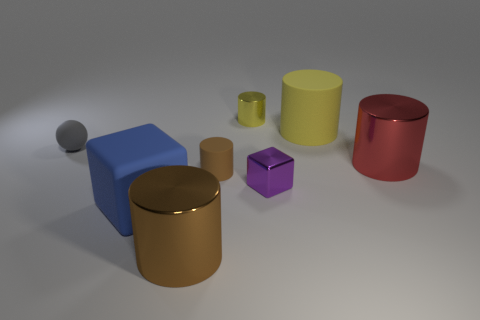Subtract all brown shiny cylinders. How many cylinders are left? 4 Subtract all red cylinders. How many cylinders are left? 4 Add 1 tiny balls. How many objects exist? 9 Subtract all blue cylinders. Subtract all cyan spheres. How many cylinders are left? 5 Subtract all cylinders. How many objects are left? 3 Subtract all rubber cylinders. Subtract all big purple objects. How many objects are left? 6 Add 1 small purple blocks. How many small purple blocks are left? 2 Add 4 tiny gray things. How many tiny gray things exist? 5 Subtract 0 brown spheres. How many objects are left? 8 